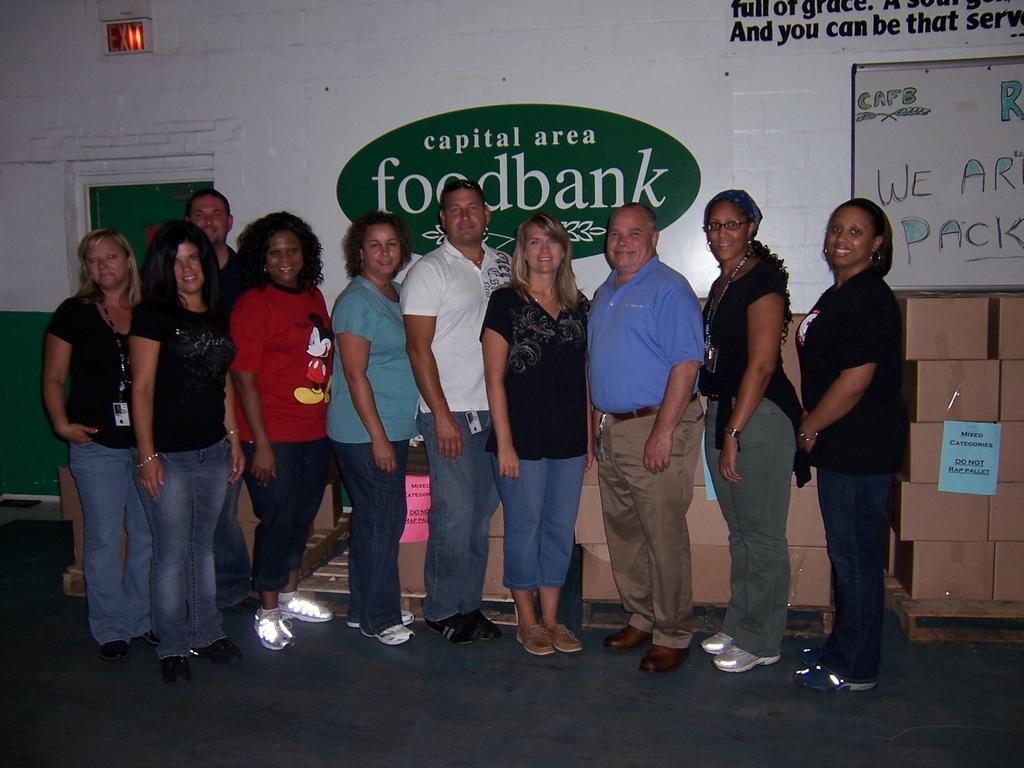In one or two sentences, can you explain what this image depicts? In this picture we can see a group of people standing on the floor and smiling, posters, board, boxes and in the background we can see a door, wall. 